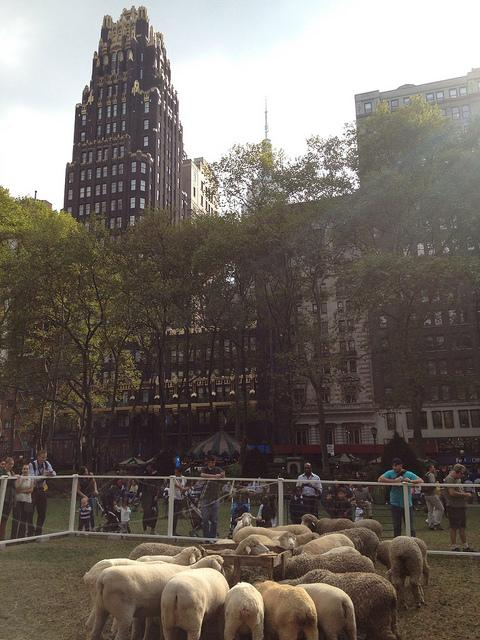What structure surrounds the animals?

Choices:
A) barn
B) pen
C) dome
D) cage pen 